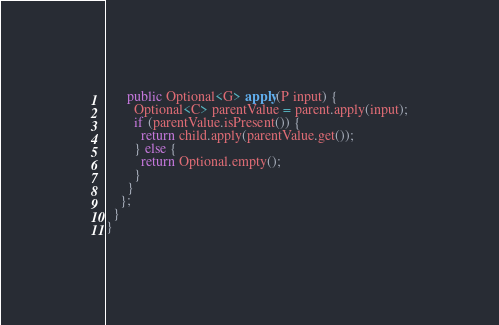<code> <loc_0><loc_0><loc_500><loc_500><_Java_>      public Optional<G> apply(P input) {
        Optional<C> parentValue = parent.apply(input);
        if (parentValue.isPresent()) {
          return child.apply(parentValue.get());
        } else {
          return Optional.empty();
        }
      }
    };
  }
}
</code> 